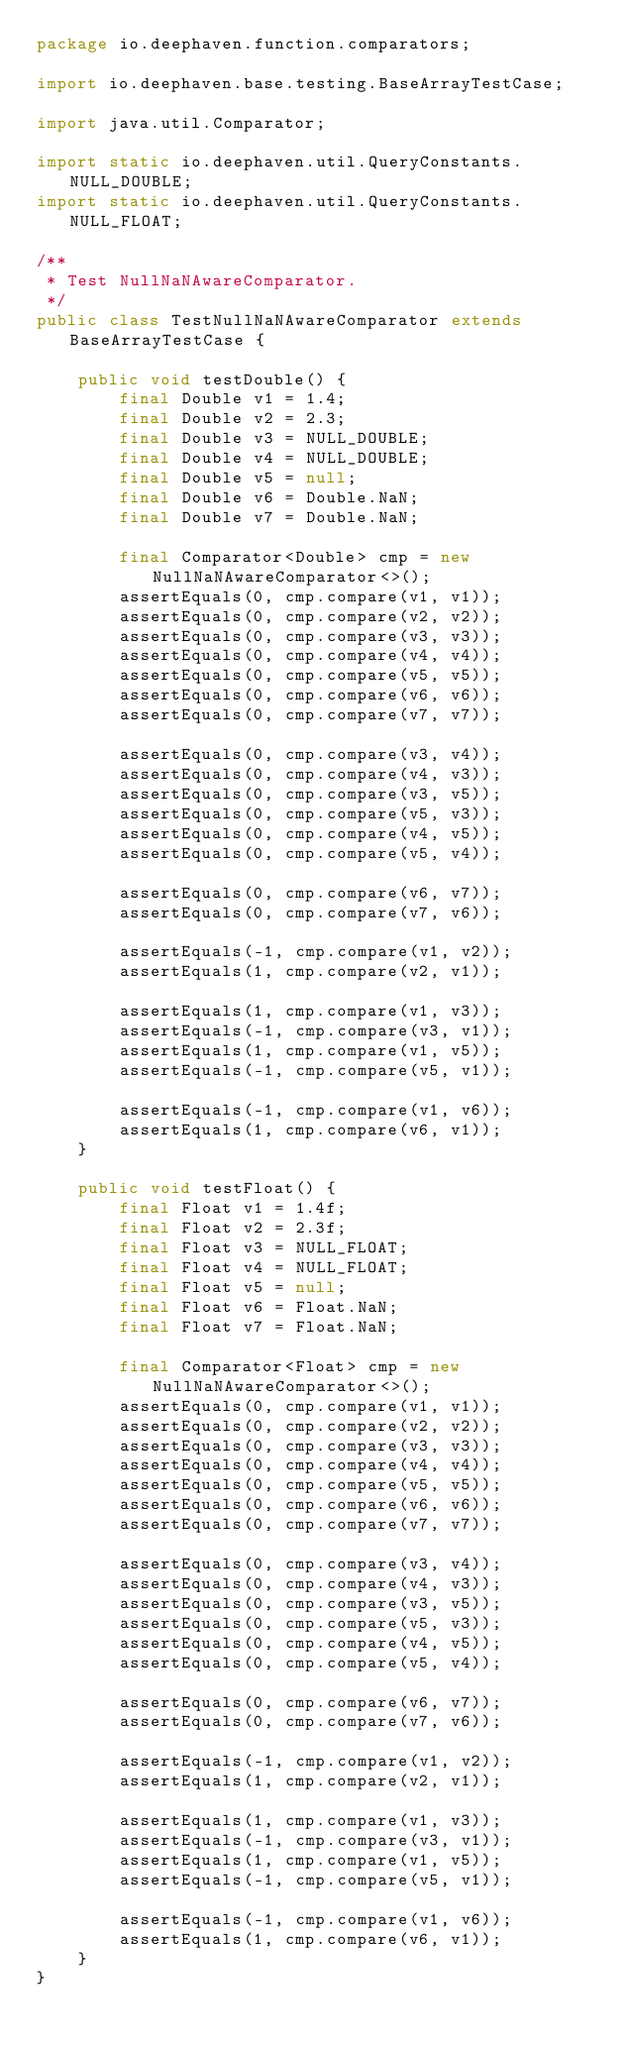<code> <loc_0><loc_0><loc_500><loc_500><_Java_>package io.deephaven.function.comparators;

import io.deephaven.base.testing.BaseArrayTestCase;

import java.util.Comparator;

import static io.deephaven.util.QueryConstants.NULL_DOUBLE;
import static io.deephaven.util.QueryConstants.NULL_FLOAT;

/**
 * Test NullNaNAwareComparator.
 */
public class TestNullNaNAwareComparator extends BaseArrayTestCase {

    public void testDouble() {
        final Double v1 = 1.4;
        final Double v2 = 2.3;
        final Double v3 = NULL_DOUBLE;
        final Double v4 = NULL_DOUBLE;
        final Double v5 = null;
        final Double v6 = Double.NaN;
        final Double v7 = Double.NaN;

        final Comparator<Double> cmp = new NullNaNAwareComparator<>();
        assertEquals(0, cmp.compare(v1, v1));
        assertEquals(0, cmp.compare(v2, v2));
        assertEquals(0, cmp.compare(v3, v3));
        assertEquals(0, cmp.compare(v4, v4));
        assertEquals(0, cmp.compare(v5, v5));
        assertEquals(0, cmp.compare(v6, v6));
        assertEquals(0, cmp.compare(v7, v7));

        assertEquals(0, cmp.compare(v3, v4));
        assertEquals(0, cmp.compare(v4, v3));
        assertEquals(0, cmp.compare(v3, v5));
        assertEquals(0, cmp.compare(v5, v3));
        assertEquals(0, cmp.compare(v4, v5));
        assertEquals(0, cmp.compare(v5, v4));

        assertEquals(0, cmp.compare(v6, v7));
        assertEquals(0, cmp.compare(v7, v6));

        assertEquals(-1, cmp.compare(v1, v2));
        assertEquals(1, cmp.compare(v2, v1));

        assertEquals(1, cmp.compare(v1, v3));
        assertEquals(-1, cmp.compare(v3, v1));
        assertEquals(1, cmp.compare(v1, v5));
        assertEquals(-1, cmp.compare(v5, v1));

        assertEquals(-1, cmp.compare(v1, v6));
        assertEquals(1, cmp.compare(v6, v1));
    }

    public void testFloat() {
        final Float v1 = 1.4f;
        final Float v2 = 2.3f;
        final Float v3 = NULL_FLOAT;
        final Float v4 = NULL_FLOAT;
        final Float v5 = null;
        final Float v6 = Float.NaN;
        final Float v7 = Float.NaN;

        final Comparator<Float> cmp = new NullNaNAwareComparator<>();
        assertEquals(0, cmp.compare(v1, v1));
        assertEquals(0, cmp.compare(v2, v2));
        assertEquals(0, cmp.compare(v3, v3));
        assertEquals(0, cmp.compare(v4, v4));
        assertEquals(0, cmp.compare(v5, v5));
        assertEquals(0, cmp.compare(v6, v6));
        assertEquals(0, cmp.compare(v7, v7));

        assertEquals(0, cmp.compare(v3, v4));
        assertEquals(0, cmp.compare(v4, v3));
        assertEquals(0, cmp.compare(v3, v5));
        assertEquals(0, cmp.compare(v5, v3));
        assertEquals(0, cmp.compare(v4, v5));
        assertEquals(0, cmp.compare(v5, v4));

        assertEquals(0, cmp.compare(v6, v7));
        assertEquals(0, cmp.compare(v7, v6));

        assertEquals(-1, cmp.compare(v1, v2));
        assertEquals(1, cmp.compare(v2, v1));

        assertEquals(1, cmp.compare(v1, v3));
        assertEquals(-1, cmp.compare(v3, v1));
        assertEquals(1, cmp.compare(v1, v5));
        assertEquals(-1, cmp.compare(v5, v1));

        assertEquals(-1, cmp.compare(v1, v6));
        assertEquals(1, cmp.compare(v6, v1));
    }
}
</code> 